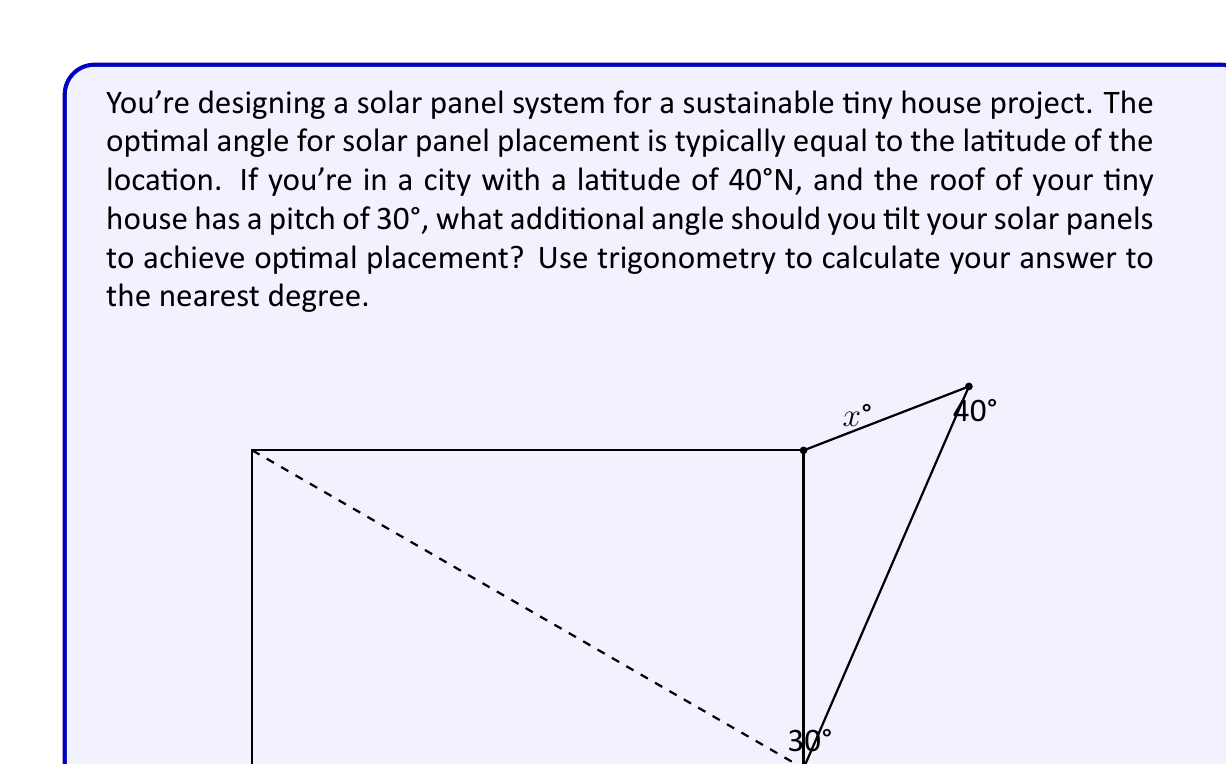Help me with this question. Let's approach this step-by-step:

1) The optimal angle for the solar panels is 40° (equal to the latitude).

2) The roof already has a pitch of 30°, so we need to find the additional angle (let's call it $x$) to reach 40°.

3) We can set up the equation:

   $30° + x° = 40°$

4) Solving for $x$:

   $x° = 40° - 30° = 10°$

5) To verify this using trigonometry, we can consider the right triangle formed by the solar panel and the roof:

   $\tan(x) = \frac{\text{opposite}}{\text{adjacent}} = \frac{\text{additional height}}{\text{length of roof}}$

6) If we consider a unit length roof (1 unit), the additional height would be:

   $\text{additional height} = \tan(10°) \approx 0.176$

7) We can check if this additional height, combined with the roof's existing angle, gives us 40°:

   $\tan(40°) \approx 0.839$
   $\tan(30°) + 0.176 \approx 0.577 + 0.176 = 0.753$

8) The slight difference is due to rounding and the nature of trigonometric functions. The 10° additional tilt is the closest whole degree solution.

Therefore, the solar panels should be tilted an additional 10° from the roof's pitch to achieve optimal placement.
Answer: 10° 